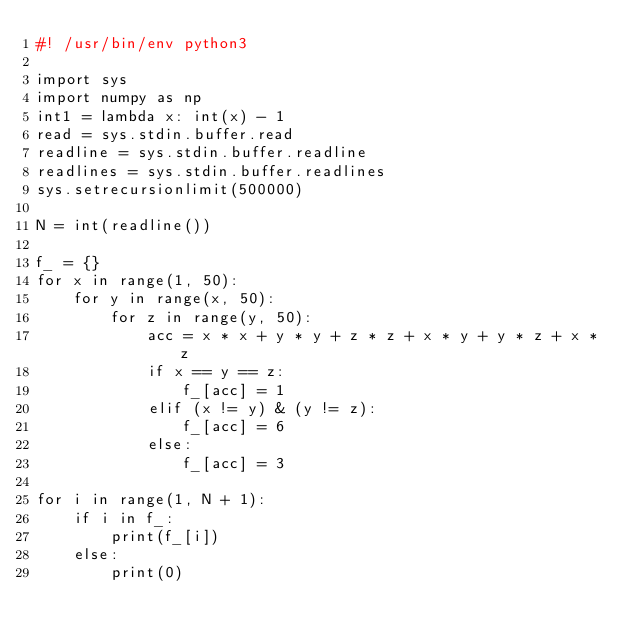Convert code to text. <code><loc_0><loc_0><loc_500><loc_500><_Python_>#! /usr/bin/env python3

import sys
import numpy as np
int1 = lambda x: int(x) - 1
read = sys.stdin.buffer.read
readline = sys.stdin.buffer.readline
readlines = sys.stdin.buffer.readlines
sys.setrecursionlimit(500000)

N = int(readline())

f_ = {}
for x in range(1, 50):
    for y in range(x, 50):
        for z in range(y, 50):
            acc = x * x + y * y + z * z + x * y + y * z + x * z
            if x == y == z:
                f_[acc] = 1
            elif (x != y) & (y != z):
                f_[acc] = 6
            else:
                f_[acc] = 3

for i in range(1, N + 1):
    if i in f_:
        print(f_[i])
    else:
        print(0)
</code> 